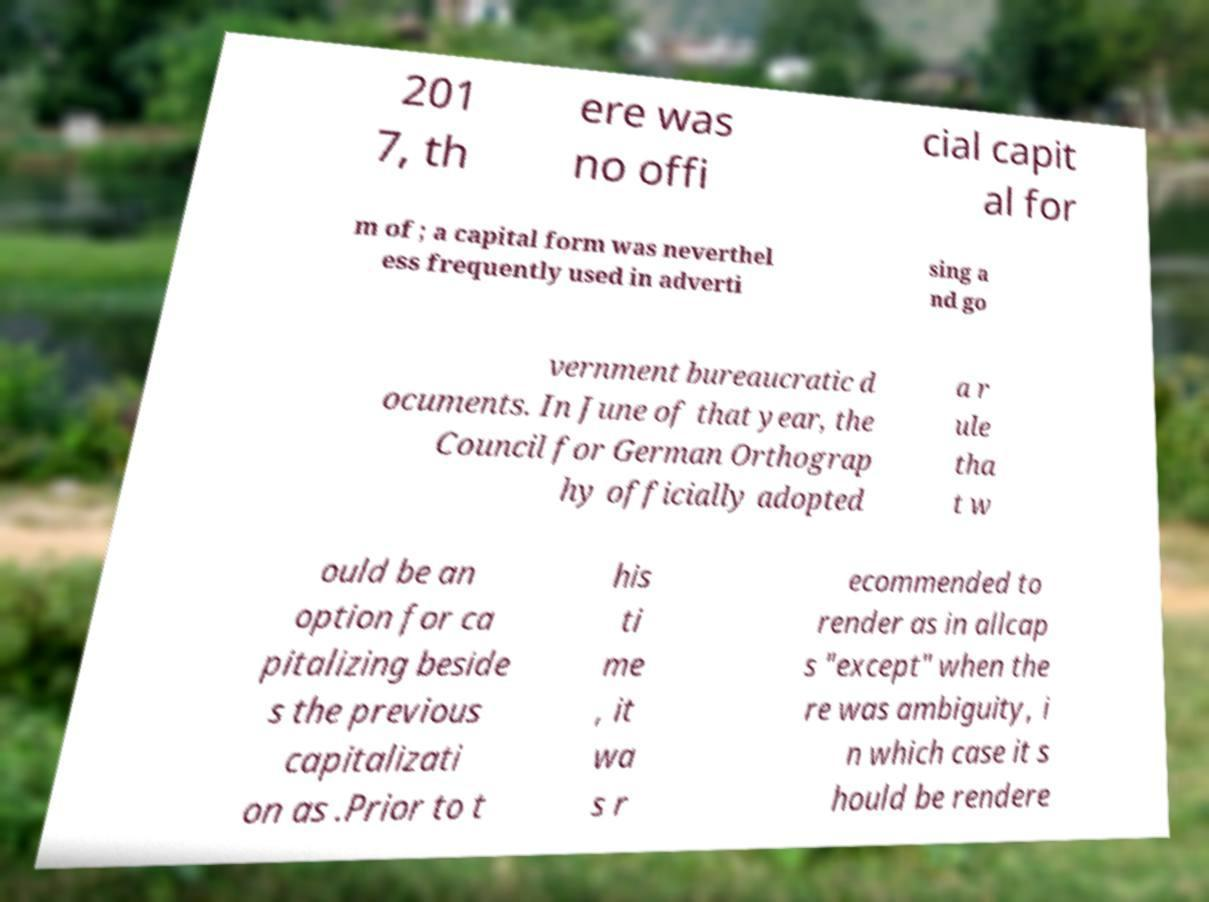Please read and relay the text visible in this image. What does it say? 201 7, th ere was no offi cial capit al for m of ; a capital form was neverthel ess frequently used in adverti sing a nd go vernment bureaucratic d ocuments. In June of that year, the Council for German Orthograp hy officially adopted a r ule tha t w ould be an option for ca pitalizing beside s the previous capitalizati on as .Prior to t his ti me , it wa s r ecommended to render as in allcap s "except" when the re was ambiguity, i n which case it s hould be rendere 